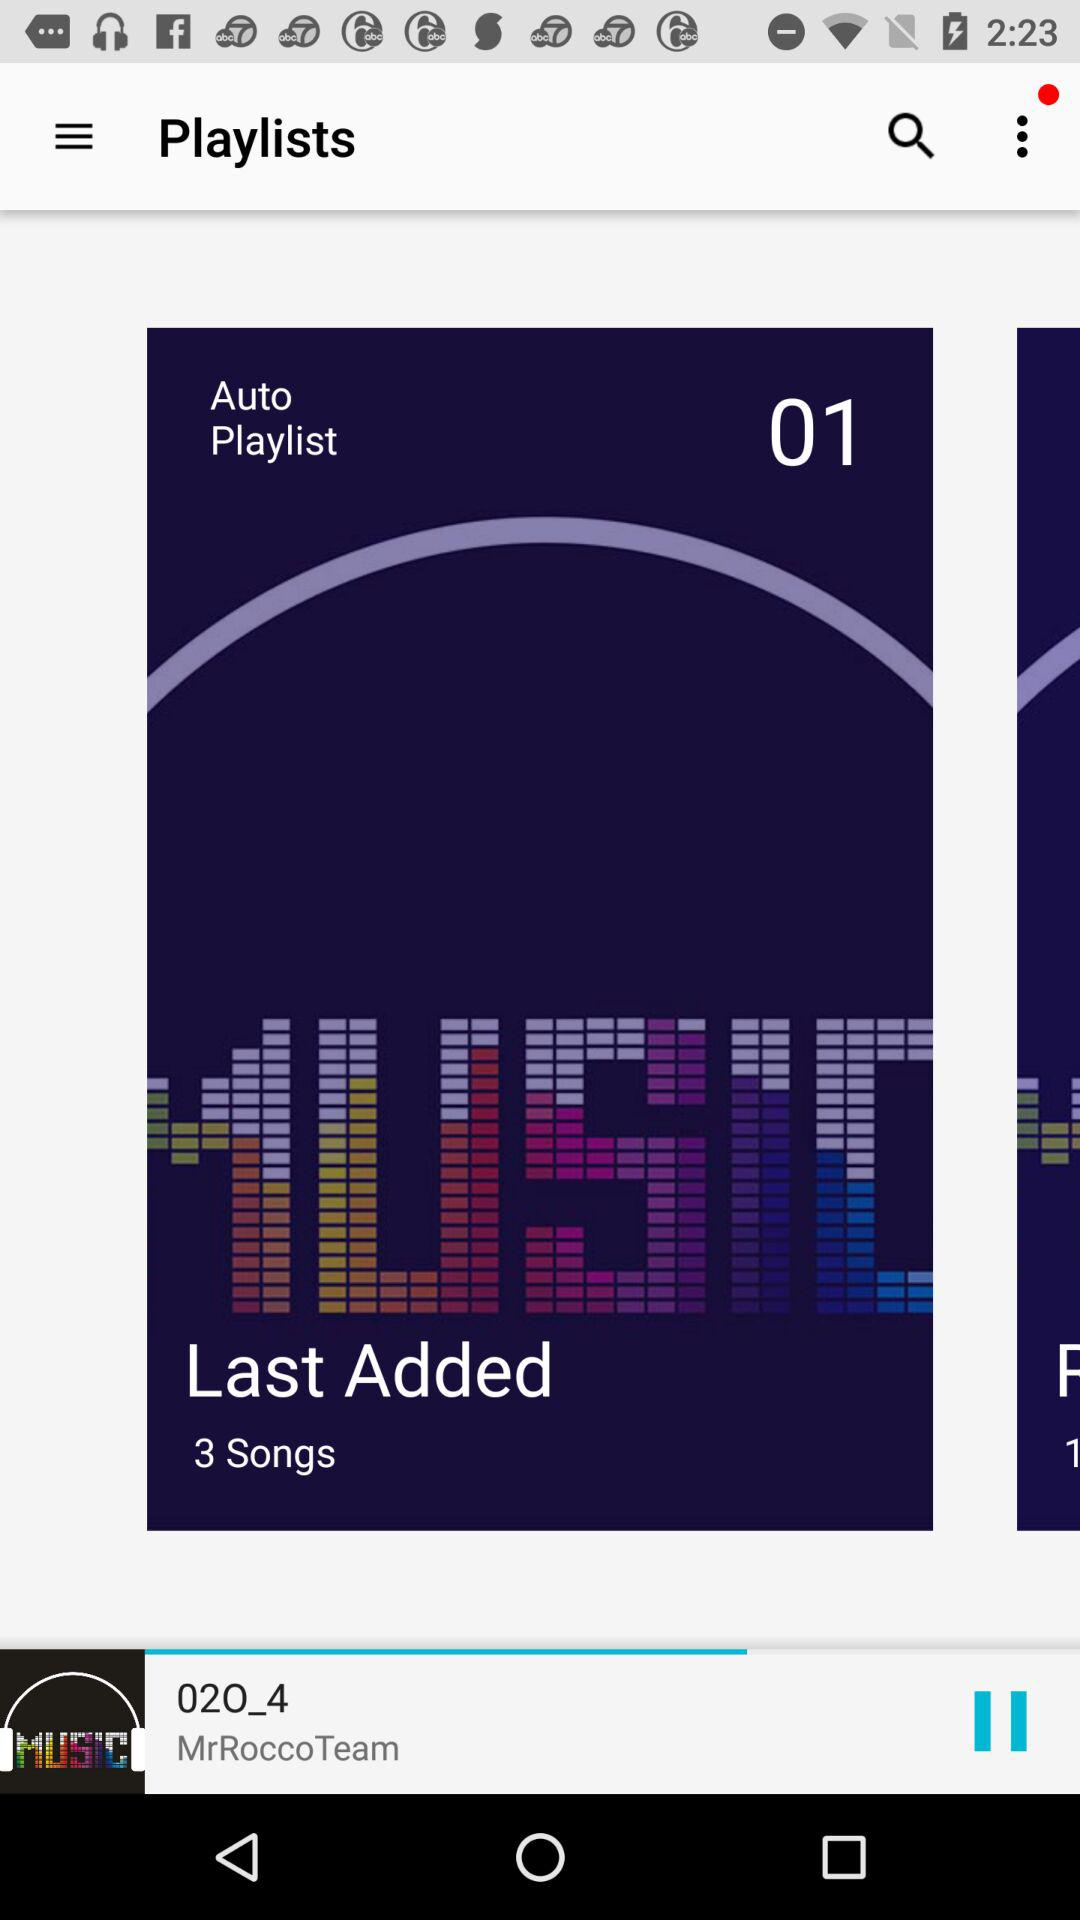Which song is playing on the screen? The song that is playing on the screen is "02O_4". 